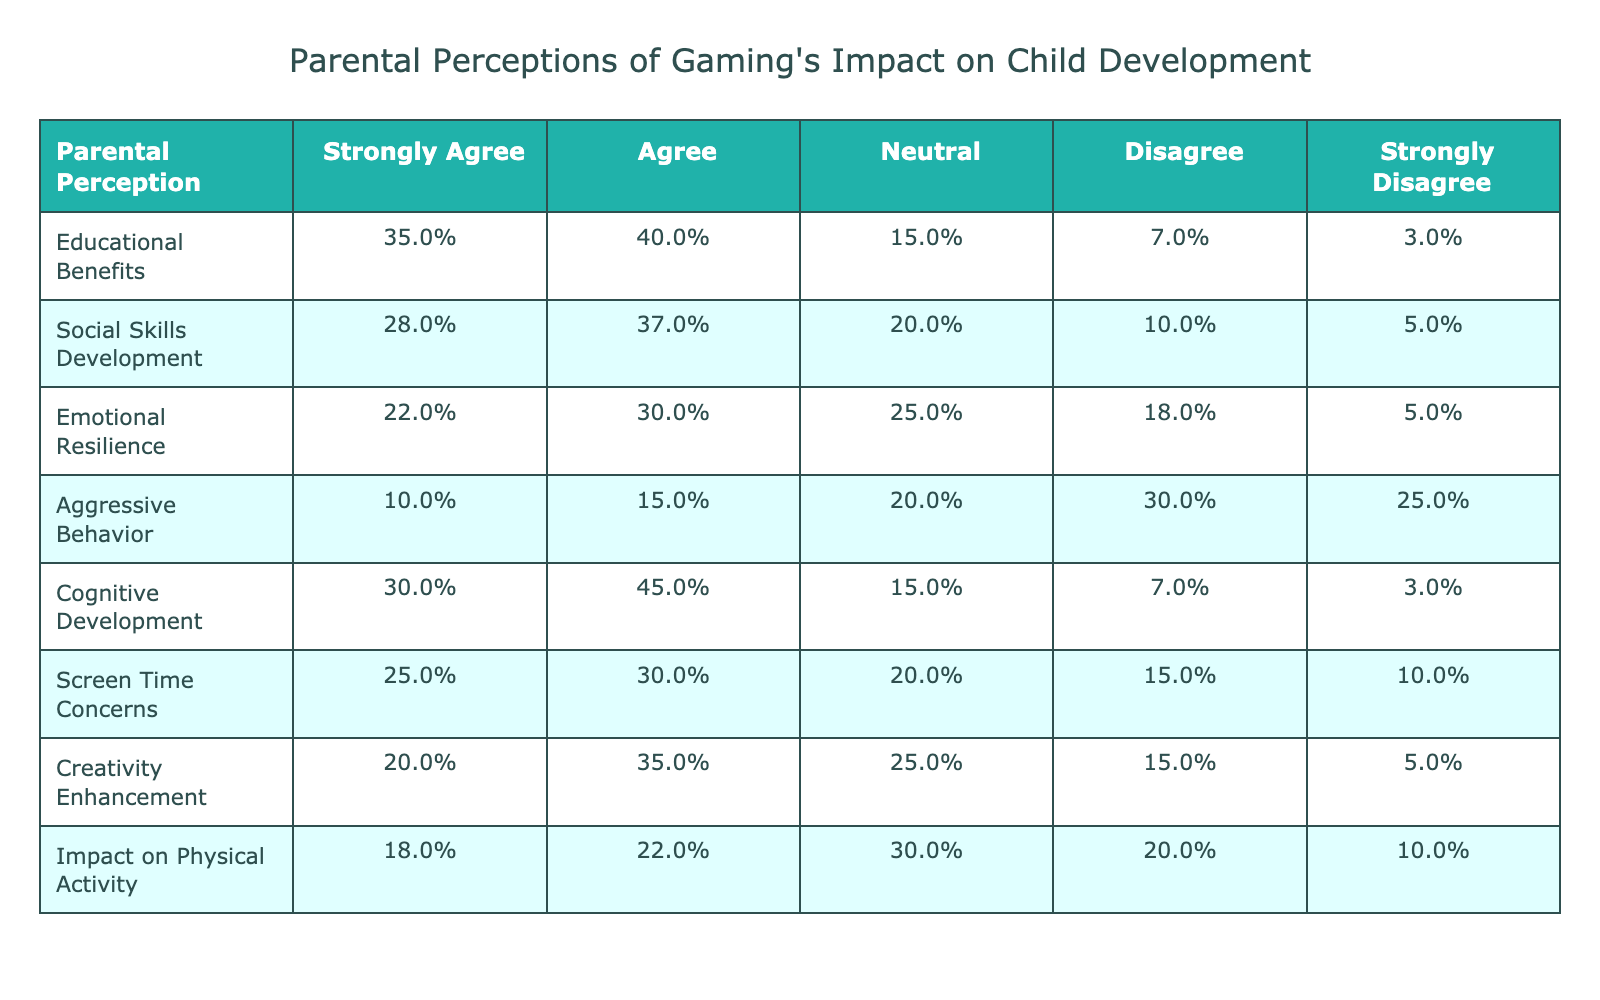What percentage of parents strongly agree that gaming has educational benefits? According to the table under "Educational Benefits," 35% of parents strongly agree that gaming has educational benefits.
Answer: 35% What is the total percentage of parents who agree or strongly agree that gaming enhances creativity? To find this, we add the percentages of "Strongly Agree" (20%) and "Agree" (35%) from the "Creativity Enhancement" row. So, 20% + 35% = 55%.
Answer: 55% Is there a greater perception of gaming positively affecting cognitive development or emotional resilience? Comparing "Cognitive Development" (75% agree or strongly agree) to "Emotional Resilience" (52% agree or strongly agree), cognitive development (30% + 45% = 75%) is viewed more positively.
Answer: Yes What percentage of parents believe gaming contributes to aggressive behavior? The "Aggressive Behavior" row shows that 10% strongly agree and 15% agree, leading to a total of 25% believing in a positive contribution.
Answer: 25% What is the difference in the percentage of parents who strongly agree that gaming impacts physical activity compared to those who strongly agree it enhances social skills? The percentage for "Impact on Physical Activity" is 18% and for "Social Skills Development" is 28%. The difference is 28% - 18% = 10%.
Answer: 10% Are parents more concerned about screen time than gaming affecting emotional resilience? Looking at the "Screen Time Concerns" row, 25% strongly agree, while in "Emotional Resilience," only 22% strongly agree. Thus, they are more concerned about screen time.
Answer: Yes What is the average percentage of parents agreeing or strongly agreeing across all categories? To calculate the average, sum the percentages of those who agree and strongly agree for each category, then divide by 8. The total sum is 35 + 40 + 28 + 37 + 22 + 30 + 20 + 35 + 30 + 45 + 25 + 15 + 10 + 30 + 18 + 22 = 408%. Dividing by 8 gives an average of 51%.
Answer: 51% Which category has the lowest percentage of parents strongly agreeing about its positive effects? "Aggressive Behavior" has the lowest percentage of strong agreement at 10%.
Answer: 10% 